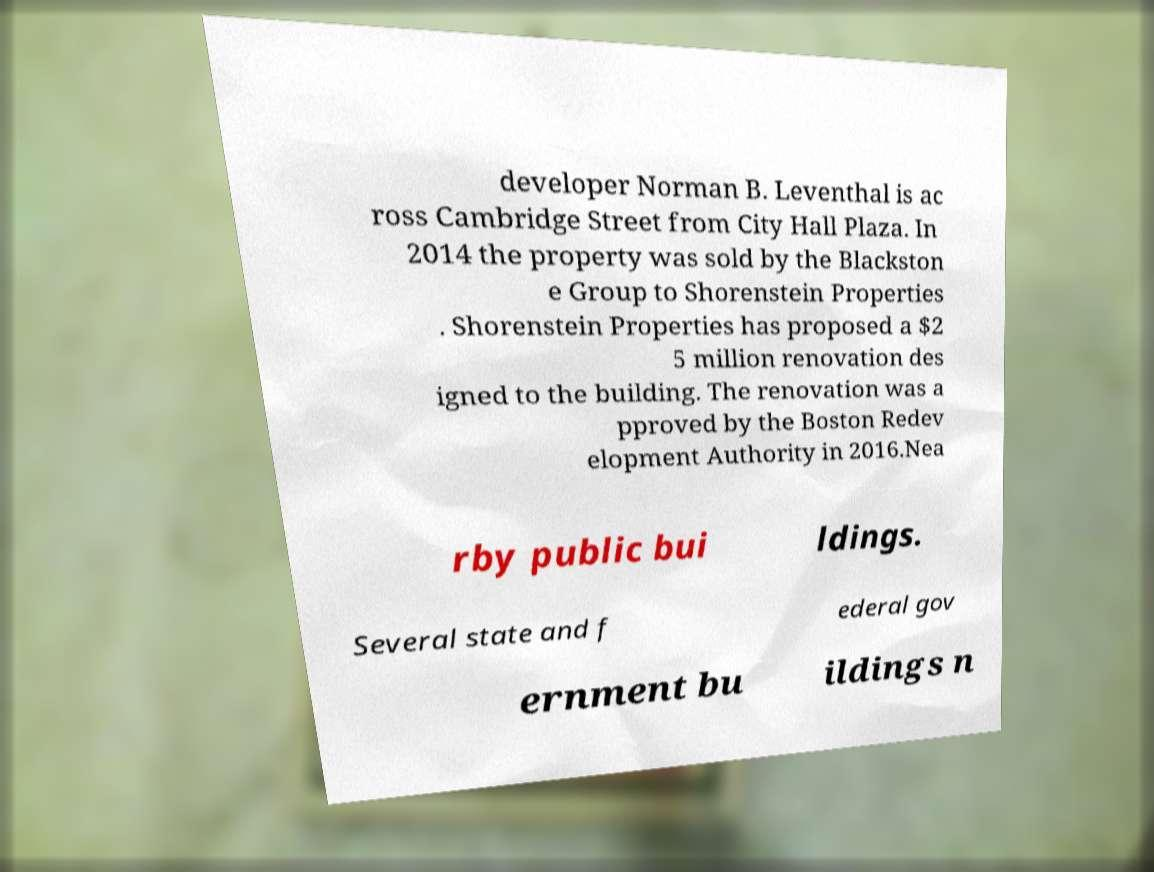I need the written content from this picture converted into text. Can you do that? developer Norman B. Leventhal is ac ross Cambridge Street from City Hall Plaza. In 2014 the property was sold by the Blackston e Group to Shorenstein Properties . Shorenstein Properties has proposed a $2 5 million renovation des igned to the building. The renovation was a pproved by the Boston Redev elopment Authority in 2016.Nea rby public bui ldings. Several state and f ederal gov ernment bu ildings n 